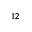Convert formula to latex. <formula><loc_0><loc_0><loc_500><loc_500>^ { 1 2 }</formula> 